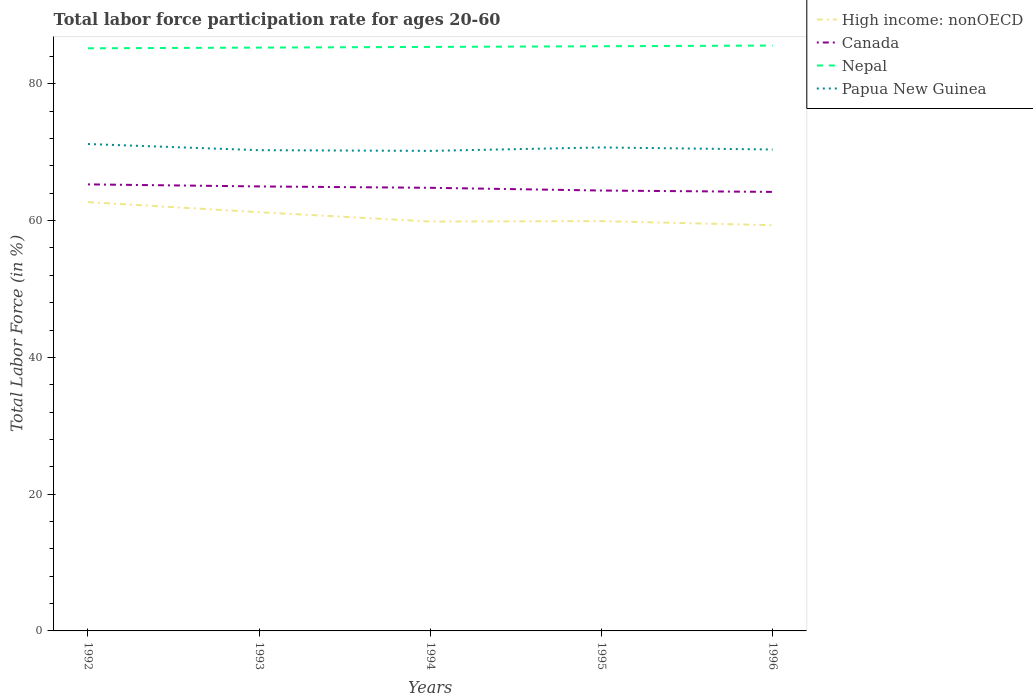Across all years, what is the maximum labor force participation rate in Canada?
Make the answer very short. 64.2. In which year was the labor force participation rate in Papua New Guinea maximum?
Your response must be concise. 1994. What is the total labor force participation rate in Papua New Guinea in the graph?
Offer a terse response. -0.1. What is the difference between the highest and the second highest labor force participation rate in Nepal?
Offer a terse response. 0.4. Are the values on the major ticks of Y-axis written in scientific E-notation?
Offer a very short reply. No. Does the graph contain any zero values?
Your answer should be compact. No. Does the graph contain grids?
Provide a succinct answer. No. How many legend labels are there?
Provide a succinct answer. 4. How are the legend labels stacked?
Your answer should be compact. Vertical. What is the title of the graph?
Offer a very short reply. Total labor force participation rate for ages 20-60. Does "Mexico" appear as one of the legend labels in the graph?
Offer a terse response. No. What is the label or title of the X-axis?
Your response must be concise. Years. What is the label or title of the Y-axis?
Ensure brevity in your answer.  Total Labor Force (in %). What is the Total Labor Force (in %) of High income: nonOECD in 1992?
Your response must be concise. 62.71. What is the Total Labor Force (in %) in Canada in 1992?
Give a very brief answer. 65.3. What is the Total Labor Force (in %) in Nepal in 1992?
Provide a short and direct response. 85.2. What is the Total Labor Force (in %) in Papua New Guinea in 1992?
Provide a short and direct response. 71.2. What is the Total Labor Force (in %) of High income: nonOECD in 1993?
Ensure brevity in your answer.  61.23. What is the Total Labor Force (in %) of Canada in 1993?
Offer a very short reply. 65. What is the Total Labor Force (in %) in Nepal in 1993?
Your answer should be compact. 85.3. What is the Total Labor Force (in %) in Papua New Guinea in 1993?
Provide a succinct answer. 70.3. What is the Total Labor Force (in %) of High income: nonOECD in 1994?
Provide a short and direct response. 59.87. What is the Total Labor Force (in %) in Canada in 1994?
Give a very brief answer. 64.8. What is the Total Labor Force (in %) of Nepal in 1994?
Make the answer very short. 85.4. What is the Total Labor Force (in %) of Papua New Guinea in 1994?
Your answer should be compact. 70.2. What is the Total Labor Force (in %) in High income: nonOECD in 1995?
Keep it short and to the point. 59.93. What is the Total Labor Force (in %) of Canada in 1995?
Your answer should be compact. 64.4. What is the Total Labor Force (in %) in Nepal in 1995?
Your answer should be very brief. 85.5. What is the Total Labor Force (in %) of Papua New Guinea in 1995?
Offer a very short reply. 70.7. What is the Total Labor Force (in %) in High income: nonOECD in 1996?
Give a very brief answer. 59.33. What is the Total Labor Force (in %) of Canada in 1996?
Give a very brief answer. 64.2. What is the Total Labor Force (in %) of Nepal in 1996?
Offer a terse response. 85.6. What is the Total Labor Force (in %) of Papua New Guinea in 1996?
Provide a short and direct response. 70.4. Across all years, what is the maximum Total Labor Force (in %) of High income: nonOECD?
Your answer should be very brief. 62.71. Across all years, what is the maximum Total Labor Force (in %) of Canada?
Provide a succinct answer. 65.3. Across all years, what is the maximum Total Labor Force (in %) in Nepal?
Provide a succinct answer. 85.6. Across all years, what is the maximum Total Labor Force (in %) in Papua New Guinea?
Your answer should be very brief. 71.2. Across all years, what is the minimum Total Labor Force (in %) in High income: nonOECD?
Your response must be concise. 59.33. Across all years, what is the minimum Total Labor Force (in %) in Canada?
Ensure brevity in your answer.  64.2. Across all years, what is the minimum Total Labor Force (in %) of Nepal?
Make the answer very short. 85.2. Across all years, what is the minimum Total Labor Force (in %) in Papua New Guinea?
Offer a very short reply. 70.2. What is the total Total Labor Force (in %) in High income: nonOECD in the graph?
Provide a succinct answer. 303.06. What is the total Total Labor Force (in %) in Canada in the graph?
Ensure brevity in your answer.  323.7. What is the total Total Labor Force (in %) in Nepal in the graph?
Keep it short and to the point. 427. What is the total Total Labor Force (in %) in Papua New Guinea in the graph?
Provide a succinct answer. 352.8. What is the difference between the Total Labor Force (in %) of High income: nonOECD in 1992 and that in 1993?
Provide a succinct answer. 1.47. What is the difference between the Total Labor Force (in %) in Canada in 1992 and that in 1993?
Your response must be concise. 0.3. What is the difference between the Total Labor Force (in %) of Nepal in 1992 and that in 1993?
Offer a terse response. -0.1. What is the difference between the Total Labor Force (in %) in High income: nonOECD in 1992 and that in 1994?
Your answer should be very brief. 2.84. What is the difference between the Total Labor Force (in %) of Canada in 1992 and that in 1994?
Offer a terse response. 0.5. What is the difference between the Total Labor Force (in %) of Nepal in 1992 and that in 1994?
Your response must be concise. -0.2. What is the difference between the Total Labor Force (in %) in High income: nonOECD in 1992 and that in 1995?
Provide a succinct answer. 2.78. What is the difference between the Total Labor Force (in %) of Canada in 1992 and that in 1995?
Your answer should be very brief. 0.9. What is the difference between the Total Labor Force (in %) of Nepal in 1992 and that in 1995?
Provide a short and direct response. -0.3. What is the difference between the Total Labor Force (in %) of High income: nonOECD in 1992 and that in 1996?
Provide a succinct answer. 3.38. What is the difference between the Total Labor Force (in %) of Canada in 1992 and that in 1996?
Ensure brevity in your answer.  1.1. What is the difference between the Total Labor Force (in %) in Nepal in 1992 and that in 1996?
Offer a terse response. -0.4. What is the difference between the Total Labor Force (in %) of High income: nonOECD in 1993 and that in 1994?
Provide a short and direct response. 1.37. What is the difference between the Total Labor Force (in %) in Nepal in 1993 and that in 1994?
Your answer should be very brief. -0.1. What is the difference between the Total Labor Force (in %) in Papua New Guinea in 1993 and that in 1994?
Your response must be concise. 0.1. What is the difference between the Total Labor Force (in %) in High income: nonOECD in 1993 and that in 1995?
Your answer should be compact. 1.3. What is the difference between the Total Labor Force (in %) in Papua New Guinea in 1993 and that in 1995?
Provide a succinct answer. -0.4. What is the difference between the Total Labor Force (in %) of High income: nonOECD in 1993 and that in 1996?
Give a very brief answer. 1.9. What is the difference between the Total Labor Force (in %) of Nepal in 1993 and that in 1996?
Your answer should be very brief. -0.3. What is the difference between the Total Labor Force (in %) in High income: nonOECD in 1994 and that in 1995?
Ensure brevity in your answer.  -0.06. What is the difference between the Total Labor Force (in %) of Canada in 1994 and that in 1995?
Give a very brief answer. 0.4. What is the difference between the Total Labor Force (in %) in Nepal in 1994 and that in 1995?
Keep it short and to the point. -0.1. What is the difference between the Total Labor Force (in %) in Papua New Guinea in 1994 and that in 1995?
Your answer should be very brief. -0.5. What is the difference between the Total Labor Force (in %) of High income: nonOECD in 1994 and that in 1996?
Keep it short and to the point. 0.54. What is the difference between the Total Labor Force (in %) in Papua New Guinea in 1994 and that in 1996?
Give a very brief answer. -0.2. What is the difference between the Total Labor Force (in %) of High income: nonOECD in 1995 and that in 1996?
Your response must be concise. 0.6. What is the difference between the Total Labor Force (in %) in Canada in 1995 and that in 1996?
Your response must be concise. 0.2. What is the difference between the Total Labor Force (in %) in Nepal in 1995 and that in 1996?
Offer a terse response. -0.1. What is the difference between the Total Labor Force (in %) of High income: nonOECD in 1992 and the Total Labor Force (in %) of Canada in 1993?
Your answer should be very brief. -2.29. What is the difference between the Total Labor Force (in %) of High income: nonOECD in 1992 and the Total Labor Force (in %) of Nepal in 1993?
Provide a succinct answer. -22.59. What is the difference between the Total Labor Force (in %) in High income: nonOECD in 1992 and the Total Labor Force (in %) in Papua New Guinea in 1993?
Make the answer very short. -7.59. What is the difference between the Total Labor Force (in %) in Nepal in 1992 and the Total Labor Force (in %) in Papua New Guinea in 1993?
Make the answer very short. 14.9. What is the difference between the Total Labor Force (in %) of High income: nonOECD in 1992 and the Total Labor Force (in %) of Canada in 1994?
Offer a terse response. -2.09. What is the difference between the Total Labor Force (in %) of High income: nonOECD in 1992 and the Total Labor Force (in %) of Nepal in 1994?
Your response must be concise. -22.69. What is the difference between the Total Labor Force (in %) in High income: nonOECD in 1992 and the Total Labor Force (in %) in Papua New Guinea in 1994?
Provide a succinct answer. -7.49. What is the difference between the Total Labor Force (in %) in Canada in 1992 and the Total Labor Force (in %) in Nepal in 1994?
Your response must be concise. -20.1. What is the difference between the Total Labor Force (in %) of Canada in 1992 and the Total Labor Force (in %) of Papua New Guinea in 1994?
Make the answer very short. -4.9. What is the difference between the Total Labor Force (in %) in Nepal in 1992 and the Total Labor Force (in %) in Papua New Guinea in 1994?
Your answer should be very brief. 15. What is the difference between the Total Labor Force (in %) of High income: nonOECD in 1992 and the Total Labor Force (in %) of Canada in 1995?
Your answer should be very brief. -1.69. What is the difference between the Total Labor Force (in %) in High income: nonOECD in 1992 and the Total Labor Force (in %) in Nepal in 1995?
Give a very brief answer. -22.79. What is the difference between the Total Labor Force (in %) in High income: nonOECD in 1992 and the Total Labor Force (in %) in Papua New Guinea in 1995?
Keep it short and to the point. -7.99. What is the difference between the Total Labor Force (in %) in Canada in 1992 and the Total Labor Force (in %) in Nepal in 1995?
Provide a succinct answer. -20.2. What is the difference between the Total Labor Force (in %) in Canada in 1992 and the Total Labor Force (in %) in Papua New Guinea in 1995?
Your answer should be very brief. -5.4. What is the difference between the Total Labor Force (in %) of Nepal in 1992 and the Total Labor Force (in %) of Papua New Guinea in 1995?
Provide a short and direct response. 14.5. What is the difference between the Total Labor Force (in %) in High income: nonOECD in 1992 and the Total Labor Force (in %) in Canada in 1996?
Your answer should be very brief. -1.49. What is the difference between the Total Labor Force (in %) of High income: nonOECD in 1992 and the Total Labor Force (in %) of Nepal in 1996?
Your response must be concise. -22.89. What is the difference between the Total Labor Force (in %) in High income: nonOECD in 1992 and the Total Labor Force (in %) in Papua New Guinea in 1996?
Your answer should be compact. -7.69. What is the difference between the Total Labor Force (in %) in Canada in 1992 and the Total Labor Force (in %) in Nepal in 1996?
Your response must be concise. -20.3. What is the difference between the Total Labor Force (in %) in Canada in 1992 and the Total Labor Force (in %) in Papua New Guinea in 1996?
Your response must be concise. -5.1. What is the difference between the Total Labor Force (in %) in Nepal in 1992 and the Total Labor Force (in %) in Papua New Guinea in 1996?
Offer a terse response. 14.8. What is the difference between the Total Labor Force (in %) in High income: nonOECD in 1993 and the Total Labor Force (in %) in Canada in 1994?
Your answer should be compact. -3.57. What is the difference between the Total Labor Force (in %) in High income: nonOECD in 1993 and the Total Labor Force (in %) in Nepal in 1994?
Your answer should be compact. -24.17. What is the difference between the Total Labor Force (in %) in High income: nonOECD in 1993 and the Total Labor Force (in %) in Papua New Guinea in 1994?
Your response must be concise. -8.97. What is the difference between the Total Labor Force (in %) in Canada in 1993 and the Total Labor Force (in %) in Nepal in 1994?
Your answer should be very brief. -20.4. What is the difference between the Total Labor Force (in %) in Canada in 1993 and the Total Labor Force (in %) in Papua New Guinea in 1994?
Provide a succinct answer. -5.2. What is the difference between the Total Labor Force (in %) in Nepal in 1993 and the Total Labor Force (in %) in Papua New Guinea in 1994?
Provide a succinct answer. 15.1. What is the difference between the Total Labor Force (in %) in High income: nonOECD in 1993 and the Total Labor Force (in %) in Canada in 1995?
Your answer should be very brief. -3.17. What is the difference between the Total Labor Force (in %) of High income: nonOECD in 1993 and the Total Labor Force (in %) of Nepal in 1995?
Your response must be concise. -24.27. What is the difference between the Total Labor Force (in %) in High income: nonOECD in 1993 and the Total Labor Force (in %) in Papua New Guinea in 1995?
Give a very brief answer. -9.47. What is the difference between the Total Labor Force (in %) in Canada in 1993 and the Total Labor Force (in %) in Nepal in 1995?
Your answer should be very brief. -20.5. What is the difference between the Total Labor Force (in %) in Canada in 1993 and the Total Labor Force (in %) in Papua New Guinea in 1995?
Offer a terse response. -5.7. What is the difference between the Total Labor Force (in %) in High income: nonOECD in 1993 and the Total Labor Force (in %) in Canada in 1996?
Your answer should be compact. -2.97. What is the difference between the Total Labor Force (in %) in High income: nonOECD in 1993 and the Total Labor Force (in %) in Nepal in 1996?
Offer a very short reply. -24.37. What is the difference between the Total Labor Force (in %) of High income: nonOECD in 1993 and the Total Labor Force (in %) of Papua New Guinea in 1996?
Ensure brevity in your answer.  -9.17. What is the difference between the Total Labor Force (in %) of Canada in 1993 and the Total Labor Force (in %) of Nepal in 1996?
Your answer should be very brief. -20.6. What is the difference between the Total Labor Force (in %) of Nepal in 1993 and the Total Labor Force (in %) of Papua New Guinea in 1996?
Give a very brief answer. 14.9. What is the difference between the Total Labor Force (in %) in High income: nonOECD in 1994 and the Total Labor Force (in %) in Canada in 1995?
Keep it short and to the point. -4.53. What is the difference between the Total Labor Force (in %) of High income: nonOECD in 1994 and the Total Labor Force (in %) of Nepal in 1995?
Offer a very short reply. -25.63. What is the difference between the Total Labor Force (in %) of High income: nonOECD in 1994 and the Total Labor Force (in %) of Papua New Guinea in 1995?
Provide a short and direct response. -10.83. What is the difference between the Total Labor Force (in %) in Canada in 1994 and the Total Labor Force (in %) in Nepal in 1995?
Your response must be concise. -20.7. What is the difference between the Total Labor Force (in %) of Nepal in 1994 and the Total Labor Force (in %) of Papua New Guinea in 1995?
Provide a short and direct response. 14.7. What is the difference between the Total Labor Force (in %) of High income: nonOECD in 1994 and the Total Labor Force (in %) of Canada in 1996?
Your answer should be very brief. -4.33. What is the difference between the Total Labor Force (in %) in High income: nonOECD in 1994 and the Total Labor Force (in %) in Nepal in 1996?
Your response must be concise. -25.73. What is the difference between the Total Labor Force (in %) of High income: nonOECD in 1994 and the Total Labor Force (in %) of Papua New Guinea in 1996?
Your answer should be very brief. -10.53. What is the difference between the Total Labor Force (in %) of Canada in 1994 and the Total Labor Force (in %) of Nepal in 1996?
Make the answer very short. -20.8. What is the difference between the Total Labor Force (in %) of Canada in 1994 and the Total Labor Force (in %) of Papua New Guinea in 1996?
Provide a succinct answer. -5.6. What is the difference between the Total Labor Force (in %) of High income: nonOECD in 1995 and the Total Labor Force (in %) of Canada in 1996?
Your answer should be compact. -4.27. What is the difference between the Total Labor Force (in %) in High income: nonOECD in 1995 and the Total Labor Force (in %) in Nepal in 1996?
Your response must be concise. -25.67. What is the difference between the Total Labor Force (in %) in High income: nonOECD in 1995 and the Total Labor Force (in %) in Papua New Guinea in 1996?
Offer a very short reply. -10.47. What is the difference between the Total Labor Force (in %) in Canada in 1995 and the Total Labor Force (in %) in Nepal in 1996?
Provide a succinct answer. -21.2. What is the difference between the Total Labor Force (in %) in Nepal in 1995 and the Total Labor Force (in %) in Papua New Guinea in 1996?
Make the answer very short. 15.1. What is the average Total Labor Force (in %) of High income: nonOECD per year?
Offer a very short reply. 60.61. What is the average Total Labor Force (in %) of Canada per year?
Your response must be concise. 64.74. What is the average Total Labor Force (in %) in Nepal per year?
Offer a terse response. 85.4. What is the average Total Labor Force (in %) of Papua New Guinea per year?
Give a very brief answer. 70.56. In the year 1992, what is the difference between the Total Labor Force (in %) in High income: nonOECD and Total Labor Force (in %) in Canada?
Give a very brief answer. -2.59. In the year 1992, what is the difference between the Total Labor Force (in %) in High income: nonOECD and Total Labor Force (in %) in Nepal?
Ensure brevity in your answer.  -22.49. In the year 1992, what is the difference between the Total Labor Force (in %) in High income: nonOECD and Total Labor Force (in %) in Papua New Guinea?
Keep it short and to the point. -8.49. In the year 1992, what is the difference between the Total Labor Force (in %) of Canada and Total Labor Force (in %) of Nepal?
Your answer should be very brief. -19.9. In the year 1992, what is the difference between the Total Labor Force (in %) in Canada and Total Labor Force (in %) in Papua New Guinea?
Provide a succinct answer. -5.9. In the year 1993, what is the difference between the Total Labor Force (in %) of High income: nonOECD and Total Labor Force (in %) of Canada?
Your response must be concise. -3.77. In the year 1993, what is the difference between the Total Labor Force (in %) of High income: nonOECD and Total Labor Force (in %) of Nepal?
Your answer should be very brief. -24.07. In the year 1993, what is the difference between the Total Labor Force (in %) in High income: nonOECD and Total Labor Force (in %) in Papua New Guinea?
Give a very brief answer. -9.07. In the year 1993, what is the difference between the Total Labor Force (in %) of Canada and Total Labor Force (in %) of Nepal?
Your answer should be very brief. -20.3. In the year 1993, what is the difference between the Total Labor Force (in %) in Canada and Total Labor Force (in %) in Papua New Guinea?
Make the answer very short. -5.3. In the year 1994, what is the difference between the Total Labor Force (in %) of High income: nonOECD and Total Labor Force (in %) of Canada?
Make the answer very short. -4.93. In the year 1994, what is the difference between the Total Labor Force (in %) in High income: nonOECD and Total Labor Force (in %) in Nepal?
Provide a succinct answer. -25.53. In the year 1994, what is the difference between the Total Labor Force (in %) of High income: nonOECD and Total Labor Force (in %) of Papua New Guinea?
Make the answer very short. -10.33. In the year 1994, what is the difference between the Total Labor Force (in %) in Canada and Total Labor Force (in %) in Nepal?
Keep it short and to the point. -20.6. In the year 1994, what is the difference between the Total Labor Force (in %) of Canada and Total Labor Force (in %) of Papua New Guinea?
Offer a terse response. -5.4. In the year 1995, what is the difference between the Total Labor Force (in %) in High income: nonOECD and Total Labor Force (in %) in Canada?
Offer a very short reply. -4.47. In the year 1995, what is the difference between the Total Labor Force (in %) in High income: nonOECD and Total Labor Force (in %) in Nepal?
Your response must be concise. -25.57. In the year 1995, what is the difference between the Total Labor Force (in %) in High income: nonOECD and Total Labor Force (in %) in Papua New Guinea?
Offer a terse response. -10.77. In the year 1995, what is the difference between the Total Labor Force (in %) of Canada and Total Labor Force (in %) of Nepal?
Offer a terse response. -21.1. In the year 1995, what is the difference between the Total Labor Force (in %) of Canada and Total Labor Force (in %) of Papua New Guinea?
Your answer should be very brief. -6.3. In the year 1995, what is the difference between the Total Labor Force (in %) of Nepal and Total Labor Force (in %) of Papua New Guinea?
Keep it short and to the point. 14.8. In the year 1996, what is the difference between the Total Labor Force (in %) of High income: nonOECD and Total Labor Force (in %) of Canada?
Provide a succinct answer. -4.87. In the year 1996, what is the difference between the Total Labor Force (in %) in High income: nonOECD and Total Labor Force (in %) in Nepal?
Offer a very short reply. -26.27. In the year 1996, what is the difference between the Total Labor Force (in %) in High income: nonOECD and Total Labor Force (in %) in Papua New Guinea?
Keep it short and to the point. -11.07. In the year 1996, what is the difference between the Total Labor Force (in %) in Canada and Total Labor Force (in %) in Nepal?
Your answer should be very brief. -21.4. In the year 1996, what is the difference between the Total Labor Force (in %) of Canada and Total Labor Force (in %) of Papua New Guinea?
Provide a short and direct response. -6.2. What is the ratio of the Total Labor Force (in %) in High income: nonOECD in 1992 to that in 1993?
Make the answer very short. 1.02. What is the ratio of the Total Labor Force (in %) of Canada in 1992 to that in 1993?
Keep it short and to the point. 1. What is the ratio of the Total Labor Force (in %) of Papua New Guinea in 1992 to that in 1993?
Offer a terse response. 1.01. What is the ratio of the Total Labor Force (in %) in High income: nonOECD in 1992 to that in 1994?
Ensure brevity in your answer.  1.05. What is the ratio of the Total Labor Force (in %) of Canada in 1992 to that in 1994?
Your response must be concise. 1.01. What is the ratio of the Total Labor Force (in %) in Nepal in 1992 to that in 1994?
Ensure brevity in your answer.  1. What is the ratio of the Total Labor Force (in %) in Papua New Guinea in 1992 to that in 1994?
Your answer should be very brief. 1.01. What is the ratio of the Total Labor Force (in %) in High income: nonOECD in 1992 to that in 1995?
Ensure brevity in your answer.  1.05. What is the ratio of the Total Labor Force (in %) of Canada in 1992 to that in 1995?
Your answer should be compact. 1.01. What is the ratio of the Total Labor Force (in %) in Papua New Guinea in 1992 to that in 1995?
Your answer should be very brief. 1.01. What is the ratio of the Total Labor Force (in %) in High income: nonOECD in 1992 to that in 1996?
Offer a terse response. 1.06. What is the ratio of the Total Labor Force (in %) of Canada in 1992 to that in 1996?
Keep it short and to the point. 1.02. What is the ratio of the Total Labor Force (in %) of Papua New Guinea in 1992 to that in 1996?
Give a very brief answer. 1.01. What is the ratio of the Total Labor Force (in %) in High income: nonOECD in 1993 to that in 1994?
Keep it short and to the point. 1.02. What is the ratio of the Total Labor Force (in %) of Canada in 1993 to that in 1994?
Offer a terse response. 1. What is the ratio of the Total Labor Force (in %) of Nepal in 1993 to that in 1994?
Make the answer very short. 1. What is the ratio of the Total Labor Force (in %) of High income: nonOECD in 1993 to that in 1995?
Give a very brief answer. 1.02. What is the ratio of the Total Labor Force (in %) of Canada in 1993 to that in 1995?
Your answer should be compact. 1.01. What is the ratio of the Total Labor Force (in %) of Nepal in 1993 to that in 1995?
Keep it short and to the point. 1. What is the ratio of the Total Labor Force (in %) in Papua New Guinea in 1993 to that in 1995?
Provide a succinct answer. 0.99. What is the ratio of the Total Labor Force (in %) of High income: nonOECD in 1993 to that in 1996?
Provide a short and direct response. 1.03. What is the ratio of the Total Labor Force (in %) in Canada in 1993 to that in 1996?
Offer a terse response. 1.01. What is the ratio of the Total Labor Force (in %) in Nepal in 1993 to that in 1996?
Your response must be concise. 1. What is the ratio of the Total Labor Force (in %) in High income: nonOECD in 1994 to that in 1995?
Ensure brevity in your answer.  1. What is the ratio of the Total Labor Force (in %) in Nepal in 1994 to that in 1995?
Your answer should be compact. 1. What is the ratio of the Total Labor Force (in %) in Papua New Guinea in 1994 to that in 1995?
Offer a very short reply. 0.99. What is the ratio of the Total Labor Force (in %) in Canada in 1994 to that in 1996?
Provide a short and direct response. 1.01. What is the ratio of the Total Labor Force (in %) of High income: nonOECD in 1995 to that in 1996?
Your answer should be compact. 1.01. What is the ratio of the Total Labor Force (in %) of Canada in 1995 to that in 1996?
Give a very brief answer. 1. What is the ratio of the Total Labor Force (in %) of Nepal in 1995 to that in 1996?
Ensure brevity in your answer.  1. What is the ratio of the Total Labor Force (in %) of Papua New Guinea in 1995 to that in 1996?
Provide a short and direct response. 1. What is the difference between the highest and the second highest Total Labor Force (in %) of High income: nonOECD?
Your answer should be very brief. 1.47. What is the difference between the highest and the second highest Total Labor Force (in %) in Nepal?
Give a very brief answer. 0.1. What is the difference between the highest and the lowest Total Labor Force (in %) in High income: nonOECD?
Keep it short and to the point. 3.38. What is the difference between the highest and the lowest Total Labor Force (in %) of Nepal?
Your response must be concise. 0.4. What is the difference between the highest and the lowest Total Labor Force (in %) of Papua New Guinea?
Ensure brevity in your answer.  1. 